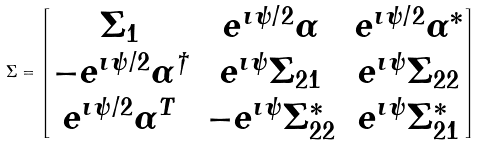Convert formula to latex. <formula><loc_0><loc_0><loc_500><loc_500>\Sigma = \begin{bmatrix} \Sigma _ { 1 } & e ^ { \imath \psi / 2 } \alpha & e ^ { \imath \psi / 2 } \alpha ^ { * } \\ - e ^ { \imath \psi / 2 } \alpha ^ { \dagger } & e ^ { \imath \psi } \Sigma _ { 2 1 } & e ^ { \imath \psi } \Sigma _ { 2 2 } \\ e ^ { \imath \psi / 2 } \alpha ^ { T } & - e ^ { \imath \psi } \Sigma _ { 2 2 } ^ { * } & e ^ { \imath \psi } \Sigma _ { 2 1 } ^ { * } \end{bmatrix}</formula> 